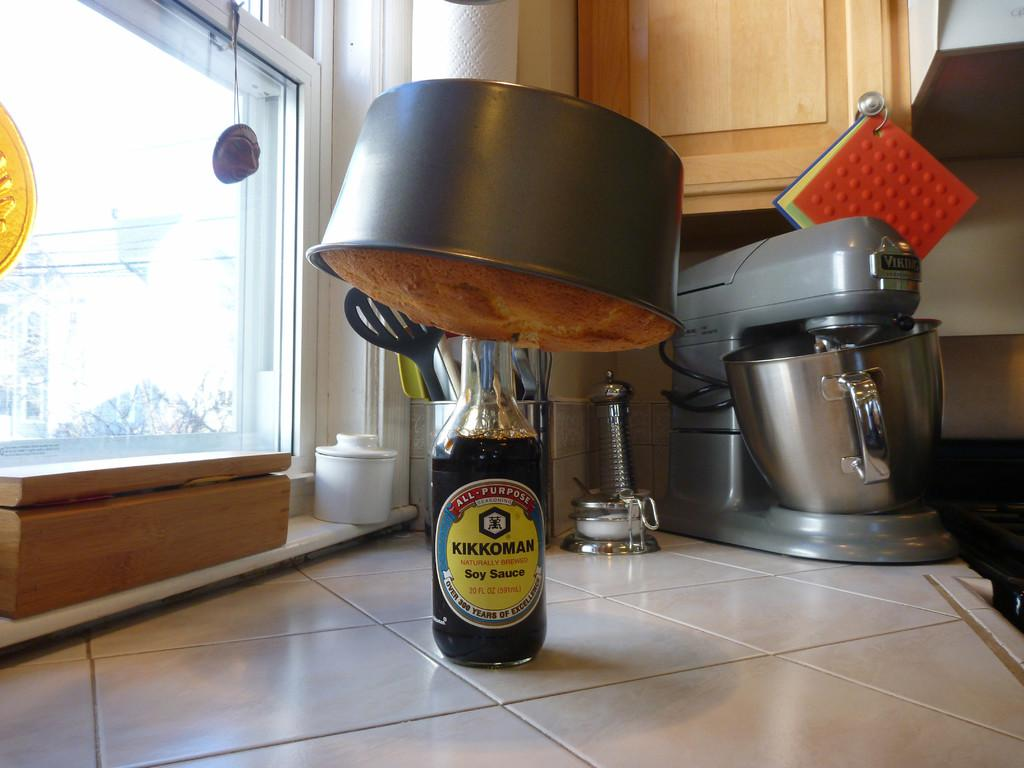Provide a one-sentence caption for the provided image. a bottle of soy sauce that is on the table. 